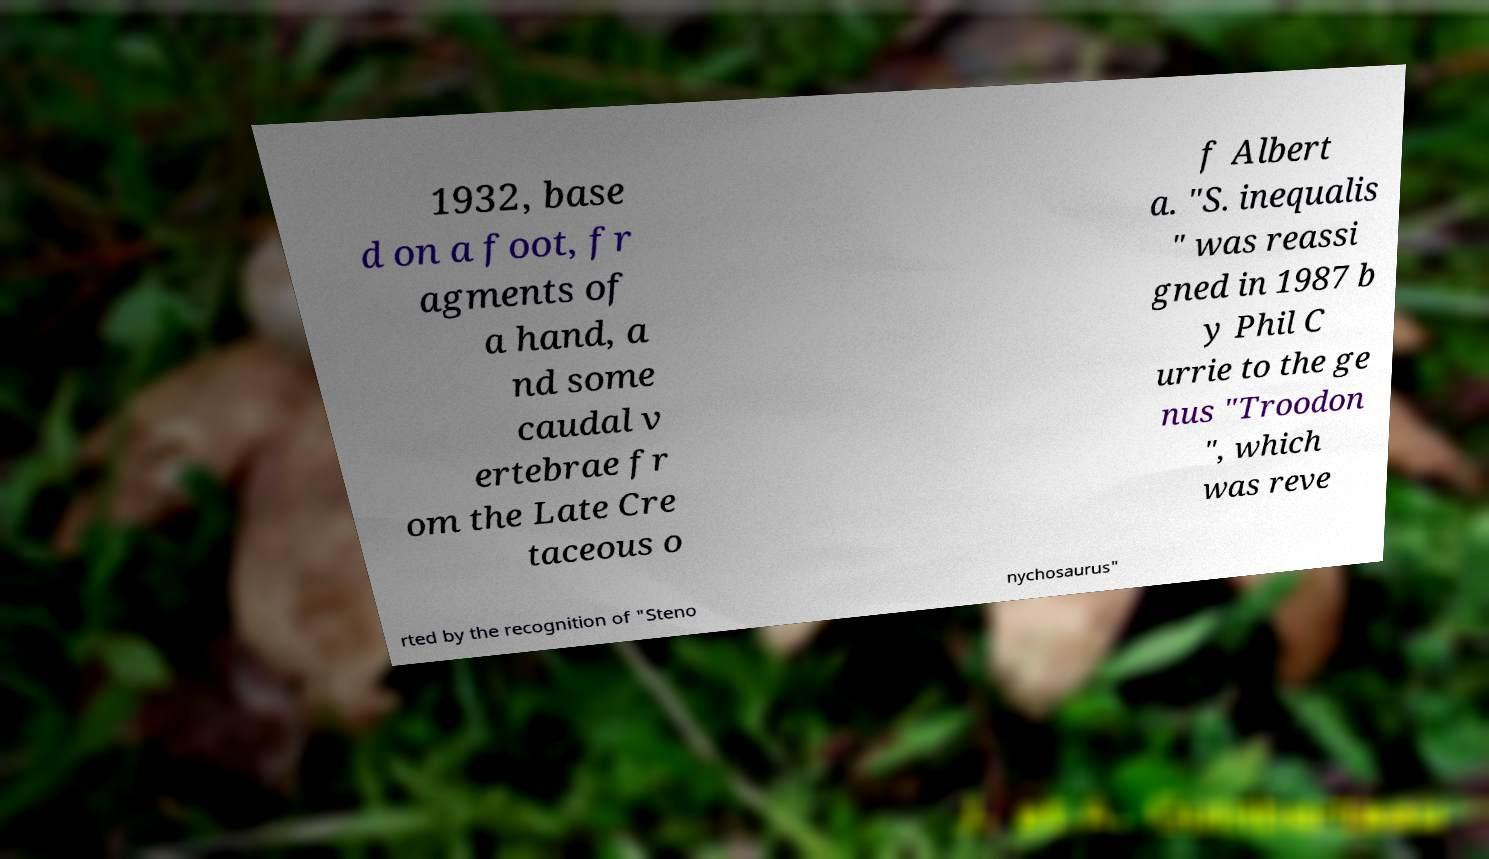I need the written content from this picture converted into text. Can you do that? 1932, base d on a foot, fr agments of a hand, a nd some caudal v ertebrae fr om the Late Cre taceous o f Albert a. "S. inequalis " was reassi gned in 1987 b y Phil C urrie to the ge nus "Troodon ", which was reve rted by the recognition of "Steno nychosaurus" 